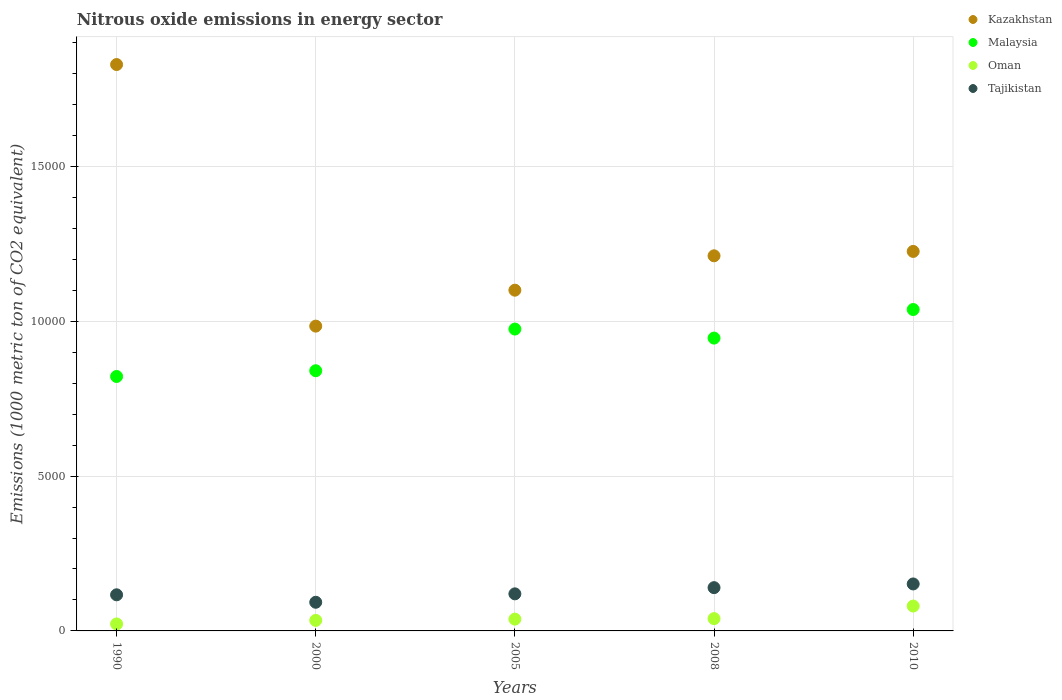How many different coloured dotlines are there?
Make the answer very short. 4. Is the number of dotlines equal to the number of legend labels?
Your answer should be very brief. Yes. What is the amount of nitrous oxide emitted in Malaysia in 1990?
Make the answer very short. 8218. Across all years, what is the maximum amount of nitrous oxide emitted in Tajikistan?
Provide a succinct answer. 1517. Across all years, what is the minimum amount of nitrous oxide emitted in Oman?
Provide a succinct answer. 225. In which year was the amount of nitrous oxide emitted in Oman minimum?
Ensure brevity in your answer.  1990. What is the total amount of nitrous oxide emitted in Malaysia in the graph?
Offer a very short reply. 4.62e+04. What is the difference between the amount of nitrous oxide emitted in Oman in 1990 and that in 2000?
Give a very brief answer. -115.4. What is the difference between the amount of nitrous oxide emitted in Malaysia in 2010 and the amount of nitrous oxide emitted in Oman in 2008?
Give a very brief answer. 9982.8. What is the average amount of nitrous oxide emitted in Tajikistan per year?
Keep it short and to the point. 1240.78. In the year 2008, what is the difference between the amount of nitrous oxide emitted in Kazakhstan and amount of nitrous oxide emitted in Tajikistan?
Make the answer very short. 1.07e+04. In how many years, is the amount of nitrous oxide emitted in Malaysia greater than 3000 1000 metric ton?
Keep it short and to the point. 5. What is the ratio of the amount of nitrous oxide emitted in Kazakhstan in 1990 to that in 2008?
Your answer should be very brief. 1.51. Is the difference between the amount of nitrous oxide emitted in Kazakhstan in 1990 and 2008 greater than the difference between the amount of nitrous oxide emitted in Tajikistan in 1990 and 2008?
Your response must be concise. Yes. What is the difference between the highest and the second highest amount of nitrous oxide emitted in Kazakhstan?
Make the answer very short. 6035.5. What is the difference between the highest and the lowest amount of nitrous oxide emitted in Oman?
Give a very brief answer. 578. In how many years, is the amount of nitrous oxide emitted in Tajikistan greater than the average amount of nitrous oxide emitted in Tajikistan taken over all years?
Give a very brief answer. 2. Is it the case that in every year, the sum of the amount of nitrous oxide emitted in Oman and amount of nitrous oxide emitted in Kazakhstan  is greater than the sum of amount of nitrous oxide emitted in Malaysia and amount of nitrous oxide emitted in Tajikistan?
Keep it short and to the point. Yes. Is it the case that in every year, the sum of the amount of nitrous oxide emitted in Kazakhstan and amount of nitrous oxide emitted in Oman  is greater than the amount of nitrous oxide emitted in Malaysia?
Your answer should be very brief. Yes. Is the amount of nitrous oxide emitted in Malaysia strictly greater than the amount of nitrous oxide emitted in Tajikistan over the years?
Keep it short and to the point. Yes. How many years are there in the graph?
Ensure brevity in your answer.  5. What is the difference between two consecutive major ticks on the Y-axis?
Your answer should be compact. 5000. Are the values on the major ticks of Y-axis written in scientific E-notation?
Give a very brief answer. No. Does the graph contain any zero values?
Offer a terse response. No. Does the graph contain grids?
Provide a succinct answer. Yes. How are the legend labels stacked?
Your response must be concise. Vertical. What is the title of the graph?
Provide a succinct answer. Nitrous oxide emissions in energy sector. What is the label or title of the X-axis?
Give a very brief answer. Years. What is the label or title of the Y-axis?
Keep it short and to the point. Emissions (1000 metric ton of CO2 equivalent). What is the Emissions (1000 metric ton of CO2 equivalent) of Kazakhstan in 1990?
Make the answer very short. 1.83e+04. What is the Emissions (1000 metric ton of CO2 equivalent) of Malaysia in 1990?
Provide a short and direct response. 8218. What is the Emissions (1000 metric ton of CO2 equivalent) of Oman in 1990?
Your response must be concise. 225. What is the Emissions (1000 metric ton of CO2 equivalent) of Tajikistan in 1990?
Offer a very short reply. 1166.5. What is the Emissions (1000 metric ton of CO2 equivalent) of Kazakhstan in 2000?
Ensure brevity in your answer.  9844.3. What is the Emissions (1000 metric ton of CO2 equivalent) in Malaysia in 2000?
Offer a very short reply. 8403.2. What is the Emissions (1000 metric ton of CO2 equivalent) of Oman in 2000?
Ensure brevity in your answer.  340.4. What is the Emissions (1000 metric ton of CO2 equivalent) in Tajikistan in 2000?
Your answer should be compact. 925.5. What is the Emissions (1000 metric ton of CO2 equivalent) of Kazakhstan in 2005?
Ensure brevity in your answer.  1.10e+04. What is the Emissions (1000 metric ton of CO2 equivalent) of Malaysia in 2005?
Your response must be concise. 9749.3. What is the Emissions (1000 metric ton of CO2 equivalent) of Oman in 2005?
Provide a succinct answer. 381.4. What is the Emissions (1000 metric ton of CO2 equivalent) of Tajikistan in 2005?
Your answer should be compact. 1197.3. What is the Emissions (1000 metric ton of CO2 equivalent) in Kazakhstan in 2008?
Make the answer very short. 1.21e+04. What is the Emissions (1000 metric ton of CO2 equivalent) of Malaysia in 2008?
Provide a succinct answer. 9457.6. What is the Emissions (1000 metric ton of CO2 equivalent) in Oman in 2008?
Keep it short and to the point. 397.4. What is the Emissions (1000 metric ton of CO2 equivalent) in Tajikistan in 2008?
Offer a very short reply. 1397.6. What is the Emissions (1000 metric ton of CO2 equivalent) in Kazakhstan in 2010?
Make the answer very short. 1.23e+04. What is the Emissions (1000 metric ton of CO2 equivalent) in Malaysia in 2010?
Give a very brief answer. 1.04e+04. What is the Emissions (1000 metric ton of CO2 equivalent) of Oman in 2010?
Give a very brief answer. 803. What is the Emissions (1000 metric ton of CO2 equivalent) in Tajikistan in 2010?
Your answer should be compact. 1517. Across all years, what is the maximum Emissions (1000 metric ton of CO2 equivalent) of Kazakhstan?
Ensure brevity in your answer.  1.83e+04. Across all years, what is the maximum Emissions (1000 metric ton of CO2 equivalent) of Malaysia?
Your response must be concise. 1.04e+04. Across all years, what is the maximum Emissions (1000 metric ton of CO2 equivalent) in Oman?
Make the answer very short. 803. Across all years, what is the maximum Emissions (1000 metric ton of CO2 equivalent) of Tajikistan?
Keep it short and to the point. 1517. Across all years, what is the minimum Emissions (1000 metric ton of CO2 equivalent) in Kazakhstan?
Your answer should be compact. 9844.3. Across all years, what is the minimum Emissions (1000 metric ton of CO2 equivalent) in Malaysia?
Give a very brief answer. 8218. Across all years, what is the minimum Emissions (1000 metric ton of CO2 equivalent) in Oman?
Your answer should be compact. 225. Across all years, what is the minimum Emissions (1000 metric ton of CO2 equivalent) of Tajikistan?
Keep it short and to the point. 925.5. What is the total Emissions (1000 metric ton of CO2 equivalent) of Kazakhstan in the graph?
Your answer should be very brief. 6.35e+04. What is the total Emissions (1000 metric ton of CO2 equivalent) in Malaysia in the graph?
Offer a very short reply. 4.62e+04. What is the total Emissions (1000 metric ton of CO2 equivalent) of Oman in the graph?
Offer a very short reply. 2147.2. What is the total Emissions (1000 metric ton of CO2 equivalent) of Tajikistan in the graph?
Offer a very short reply. 6203.9. What is the difference between the Emissions (1000 metric ton of CO2 equivalent) of Kazakhstan in 1990 and that in 2000?
Your answer should be very brief. 8448.2. What is the difference between the Emissions (1000 metric ton of CO2 equivalent) in Malaysia in 1990 and that in 2000?
Offer a terse response. -185.2. What is the difference between the Emissions (1000 metric ton of CO2 equivalent) of Oman in 1990 and that in 2000?
Your answer should be compact. -115.4. What is the difference between the Emissions (1000 metric ton of CO2 equivalent) of Tajikistan in 1990 and that in 2000?
Provide a short and direct response. 241. What is the difference between the Emissions (1000 metric ton of CO2 equivalent) in Kazakhstan in 1990 and that in 2005?
Make the answer very short. 7287.5. What is the difference between the Emissions (1000 metric ton of CO2 equivalent) of Malaysia in 1990 and that in 2005?
Your response must be concise. -1531.3. What is the difference between the Emissions (1000 metric ton of CO2 equivalent) of Oman in 1990 and that in 2005?
Provide a succinct answer. -156.4. What is the difference between the Emissions (1000 metric ton of CO2 equivalent) of Tajikistan in 1990 and that in 2005?
Your answer should be very brief. -30.8. What is the difference between the Emissions (1000 metric ton of CO2 equivalent) in Kazakhstan in 1990 and that in 2008?
Ensure brevity in your answer.  6177.4. What is the difference between the Emissions (1000 metric ton of CO2 equivalent) of Malaysia in 1990 and that in 2008?
Give a very brief answer. -1239.6. What is the difference between the Emissions (1000 metric ton of CO2 equivalent) of Oman in 1990 and that in 2008?
Make the answer very short. -172.4. What is the difference between the Emissions (1000 metric ton of CO2 equivalent) in Tajikistan in 1990 and that in 2008?
Offer a very short reply. -231.1. What is the difference between the Emissions (1000 metric ton of CO2 equivalent) of Kazakhstan in 1990 and that in 2010?
Keep it short and to the point. 6035.5. What is the difference between the Emissions (1000 metric ton of CO2 equivalent) of Malaysia in 1990 and that in 2010?
Make the answer very short. -2162.2. What is the difference between the Emissions (1000 metric ton of CO2 equivalent) of Oman in 1990 and that in 2010?
Your answer should be compact. -578. What is the difference between the Emissions (1000 metric ton of CO2 equivalent) in Tajikistan in 1990 and that in 2010?
Your response must be concise. -350.5. What is the difference between the Emissions (1000 metric ton of CO2 equivalent) in Kazakhstan in 2000 and that in 2005?
Make the answer very short. -1160.7. What is the difference between the Emissions (1000 metric ton of CO2 equivalent) of Malaysia in 2000 and that in 2005?
Offer a terse response. -1346.1. What is the difference between the Emissions (1000 metric ton of CO2 equivalent) in Oman in 2000 and that in 2005?
Ensure brevity in your answer.  -41. What is the difference between the Emissions (1000 metric ton of CO2 equivalent) in Tajikistan in 2000 and that in 2005?
Keep it short and to the point. -271.8. What is the difference between the Emissions (1000 metric ton of CO2 equivalent) in Kazakhstan in 2000 and that in 2008?
Ensure brevity in your answer.  -2270.8. What is the difference between the Emissions (1000 metric ton of CO2 equivalent) of Malaysia in 2000 and that in 2008?
Your response must be concise. -1054.4. What is the difference between the Emissions (1000 metric ton of CO2 equivalent) in Oman in 2000 and that in 2008?
Provide a succinct answer. -57. What is the difference between the Emissions (1000 metric ton of CO2 equivalent) of Tajikistan in 2000 and that in 2008?
Provide a succinct answer. -472.1. What is the difference between the Emissions (1000 metric ton of CO2 equivalent) in Kazakhstan in 2000 and that in 2010?
Provide a short and direct response. -2412.7. What is the difference between the Emissions (1000 metric ton of CO2 equivalent) in Malaysia in 2000 and that in 2010?
Ensure brevity in your answer.  -1977. What is the difference between the Emissions (1000 metric ton of CO2 equivalent) of Oman in 2000 and that in 2010?
Your response must be concise. -462.6. What is the difference between the Emissions (1000 metric ton of CO2 equivalent) of Tajikistan in 2000 and that in 2010?
Ensure brevity in your answer.  -591.5. What is the difference between the Emissions (1000 metric ton of CO2 equivalent) in Kazakhstan in 2005 and that in 2008?
Provide a short and direct response. -1110.1. What is the difference between the Emissions (1000 metric ton of CO2 equivalent) in Malaysia in 2005 and that in 2008?
Make the answer very short. 291.7. What is the difference between the Emissions (1000 metric ton of CO2 equivalent) of Tajikistan in 2005 and that in 2008?
Keep it short and to the point. -200.3. What is the difference between the Emissions (1000 metric ton of CO2 equivalent) in Kazakhstan in 2005 and that in 2010?
Your answer should be very brief. -1252. What is the difference between the Emissions (1000 metric ton of CO2 equivalent) in Malaysia in 2005 and that in 2010?
Ensure brevity in your answer.  -630.9. What is the difference between the Emissions (1000 metric ton of CO2 equivalent) of Oman in 2005 and that in 2010?
Your answer should be very brief. -421.6. What is the difference between the Emissions (1000 metric ton of CO2 equivalent) in Tajikistan in 2005 and that in 2010?
Your answer should be compact. -319.7. What is the difference between the Emissions (1000 metric ton of CO2 equivalent) of Kazakhstan in 2008 and that in 2010?
Make the answer very short. -141.9. What is the difference between the Emissions (1000 metric ton of CO2 equivalent) of Malaysia in 2008 and that in 2010?
Your response must be concise. -922.6. What is the difference between the Emissions (1000 metric ton of CO2 equivalent) in Oman in 2008 and that in 2010?
Keep it short and to the point. -405.6. What is the difference between the Emissions (1000 metric ton of CO2 equivalent) in Tajikistan in 2008 and that in 2010?
Make the answer very short. -119.4. What is the difference between the Emissions (1000 metric ton of CO2 equivalent) of Kazakhstan in 1990 and the Emissions (1000 metric ton of CO2 equivalent) of Malaysia in 2000?
Offer a terse response. 9889.3. What is the difference between the Emissions (1000 metric ton of CO2 equivalent) in Kazakhstan in 1990 and the Emissions (1000 metric ton of CO2 equivalent) in Oman in 2000?
Make the answer very short. 1.80e+04. What is the difference between the Emissions (1000 metric ton of CO2 equivalent) in Kazakhstan in 1990 and the Emissions (1000 metric ton of CO2 equivalent) in Tajikistan in 2000?
Your answer should be very brief. 1.74e+04. What is the difference between the Emissions (1000 metric ton of CO2 equivalent) of Malaysia in 1990 and the Emissions (1000 metric ton of CO2 equivalent) of Oman in 2000?
Give a very brief answer. 7877.6. What is the difference between the Emissions (1000 metric ton of CO2 equivalent) of Malaysia in 1990 and the Emissions (1000 metric ton of CO2 equivalent) of Tajikistan in 2000?
Your response must be concise. 7292.5. What is the difference between the Emissions (1000 metric ton of CO2 equivalent) in Oman in 1990 and the Emissions (1000 metric ton of CO2 equivalent) in Tajikistan in 2000?
Keep it short and to the point. -700.5. What is the difference between the Emissions (1000 metric ton of CO2 equivalent) of Kazakhstan in 1990 and the Emissions (1000 metric ton of CO2 equivalent) of Malaysia in 2005?
Offer a very short reply. 8543.2. What is the difference between the Emissions (1000 metric ton of CO2 equivalent) of Kazakhstan in 1990 and the Emissions (1000 metric ton of CO2 equivalent) of Oman in 2005?
Ensure brevity in your answer.  1.79e+04. What is the difference between the Emissions (1000 metric ton of CO2 equivalent) of Kazakhstan in 1990 and the Emissions (1000 metric ton of CO2 equivalent) of Tajikistan in 2005?
Provide a succinct answer. 1.71e+04. What is the difference between the Emissions (1000 metric ton of CO2 equivalent) of Malaysia in 1990 and the Emissions (1000 metric ton of CO2 equivalent) of Oman in 2005?
Give a very brief answer. 7836.6. What is the difference between the Emissions (1000 metric ton of CO2 equivalent) in Malaysia in 1990 and the Emissions (1000 metric ton of CO2 equivalent) in Tajikistan in 2005?
Your answer should be compact. 7020.7. What is the difference between the Emissions (1000 metric ton of CO2 equivalent) of Oman in 1990 and the Emissions (1000 metric ton of CO2 equivalent) of Tajikistan in 2005?
Keep it short and to the point. -972.3. What is the difference between the Emissions (1000 metric ton of CO2 equivalent) of Kazakhstan in 1990 and the Emissions (1000 metric ton of CO2 equivalent) of Malaysia in 2008?
Provide a succinct answer. 8834.9. What is the difference between the Emissions (1000 metric ton of CO2 equivalent) of Kazakhstan in 1990 and the Emissions (1000 metric ton of CO2 equivalent) of Oman in 2008?
Make the answer very short. 1.79e+04. What is the difference between the Emissions (1000 metric ton of CO2 equivalent) in Kazakhstan in 1990 and the Emissions (1000 metric ton of CO2 equivalent) in Tajikistan in 2008?
Provide a short and direct response. 1.69e+04. What is the difference between the Emissions (1000 metric ton of CO2 equivalent) of Malaysia in 1990 and the Emissions (1000 metric ton of CO2 equivalent) of Oman in 2008?
Ensure brevity in your answer.  7820.6. What is the difference between the Emissions (1000 metric ton of CO2 equivalent) of Malaysia in 1990 and the Emissions (1000 metric ton of CO2 equivalent) of Tajikistan in 2008?
Offer a very short reply. 6820.4. What is the difference between the Emissions (1000 metric ton of CO2 equivalent) of Oman in 1990 and the Emissions (1000 metric ton of CO2 equivalent) of Tajikistan in 2008?
Provide a short and direct response. -1172.6. What is the difference between the Emissions (1000 metric ton of CO2 equivalent) of Kazakhstan in 1990 and the Emissions (1000 metric ton of CO2 equivalent) of Malaysia in 2010?
Offer a very short reply. 7912.3. What is the difference between the Emissions (1000 metric ton of CO2 equivalent) of Kazakhstan in 1990 and the Emissions (1000 metric ton of CO2 equivalent) of Oman in 2010?
Offer a very short reply. 1.75e+04. What is the difference between the Emissions (1000 metric ton of CO2 equivalent) of Kazakhstan in 1990 and the Emissions (1000 metric ton of CO2 equivalent) of Tajikistan in 2010?
Offer a terse response. 1.68e+04. What is the difference between the Emissions (1000 metric ton of CO2 equivalent) in Malaysia in 1990 and the Emissions (1000 metric ton of CO2 equivalent) in Oman in 2010?
Your answer should be very brief. 7415. What is the difference between the Emissions (1000 metric ton of CO2 equivalent) in Malaysia in 1990 and the Emissions (1000 metric ton of CO2 equivalent) in Tajikistan in 2010?
Provide a succinct answer. 6701. What is the difference between the Emissions (1000 metric ton of CO2 equivalent) of Oman in 1990 and the Emissions (1000 metric ton of CO2 equivalent) of Tajikistan in 2010?
Ensure brevity in your answer.  -1292. What is the difference between the Emissions (1000 metric ton of CO2 equivalent) of Kazakhstan in 2000 and the Emissions (1000 metric ton of CO2 equivalent) of Malaysia in 2005?
Offer a terse response. 95. What is the difference between the Emissions (1000 metric ton of CO2 equivalent) in Kazakhstan in 2000 and the Emissions (1000 metric ton of CO2 equivalent) in Oman in 2005?
Your response must be concise. 9462.9. What is the difference between the Emissions (1000 metric ton of CO2 equivalent) in Kazakhstan in 2000 and the Emissions (1000 metric ton of CO2 equivalent) in Tajikistan in 2005?
Give a very brief answer. 8647. What is the difference between the Emissions (1000 metric ton of CO2 equivalent) in Malaysia in 2000 and the Emissions (1000 metric ton of CO2 equivalent) in Oman in 2005?
Provide a succinct answer. 8021.8. What is the difference between the Emissions (1000 metric ton of CO2 equivalent) of Malaysia in 2000 and the Emissions (1000 metric ton of CO2 equivalent) of Tajikistan in 2005?
Your answer should be very brief. 7205.9. What is the difference between the Emissions (1000 metric ton of CO2 equivalent) of Oman in 2000 and the Emissions (1000 metric ton of CO2 equivalent) of Tajikistan in 2005?
Your answer should be very brief. -856.9. What is the difference between the Emissions (1000 metric ton of CO2 equivalent) in Kazakhstan in 2000 and the Emissions (1000 metric ton of CO2 equivalent) in Malaysia in 2008?
Provide a short and direct response. 386.7. What is the difference between the Emissions (1000 metric ton of CO2 equivalent) of Kazakhstan in 2000 and the Emissions (1000 metric ton of CO2 equivalent) of Oman in 2008?
Ensure brevity in your answer.  9446.9. What is the difference between the Emissions (1000 metric ton of CO2 equivalent) in Kazakhstan in 2000 and the Emissions (1000 metric ton of CO2 equivalent) in Tajikistan in 2008?
Give a very brief answer. 8446.7. What is the difference between the Emissions (1000 metric ton of CO2 equivalent) of Malaysia in 2000 and the Emissions (1000 metric ton of CO2 equivalent) of Oman in 2008?
Ensure brevity in your answer.  8005.8. What is the difference between the Emissions (1000 metric ton of CO2 equivalent) of Malaysia in 2000 and the Emissions (1000 metric ton of CO2 equivalent) of Tajikistan in 2008?
Keep it short and to the point. 7005.6. What is the difference between the Emissions (1000 metric ton of CO2 equivalent) of Oman in 2000 and the Emissions (1000 metric ton of CO2 equivalent) of Tajikistan in 2008?
Keep it short and to the point. -1057.2. What is the difference between the Emissions (1000 metric ton of CO2 equivalent) in Kazakhstan in 2000 and the Emissions (1000 metric ton of CO2 equivalent) in Malaysia in 2010?
Your response must be concise. -535.9. What is the difference between the Emissions (1000 metric ton of CO2 equivalent) in Kazakhstan in 2000 and the Emissions (1000 metric ton of CO2 equivalent) in Oman in 2010?
Keep it short and to the point. 9041.3. What is the difference between the Emissions (1000 metric ton of CO2 equivalent) in Kazakhstan in 2000 and the Emissions (1000 metric ton of CO2 equivalent) in Tajikistan in 2010?
Keep it short and to the point. 8327.3. What is the difference between the Emissions (1000 metric ton of CO2 equivalent) of Malaysia in 2000 and the Emissions (1000 metric ton of CO2 equivalent) of Oman in 2010?
Provide a succinct answer. 7600.2. What is the difference between the Emissions (1000 metric ton of CO2 equivalent) of Malaysia in 2000 and the Emissions (1000 metric ton of CO2 equivalent) of Tajikistan in 2010?
Give a very brief answer. 6886.2. What is the difference between the Emissions (1000 metric ton of CO2 equivalent) of Oman in 2000 and the Emissions (1000 metric ton of CO2 equivalent) of Tajikistan in 2010?
Keep it short and to the point. -1176.6. What is the difference between the Emissions (1000 metric ton of CO2 equivalent) of Kazakhstan in 2005 and the Emissions (1000 metric ton of CO2 equivalent) of Malaysia in 2008?
Your response must be concise. 1547.4. What is the difference between the Emissions (1000 metric ton of CO2 equivalent) in Kazakhstan in 2005 and the Emissions (1000 metric ton of CO2 equivalent) in Oman in 2008?
Provide a succinct answer. 1.06e+04. What is the difference between the Emissions (1000 metric ton of CO2 equivalent) of Kazakhstan in 2005 and the Emissions (1000 metric ton of CO2 equivalent) of Tajikistan in 2008?
Provide a short and direct response. 9607.4. What is the difference between the Emissions (1000 metric ton of CO2 equivalent) in Malaysia in 2005 and the Emissions (1000 metric ton of CO2 equivalent) in Oman in 2008?
Keep it short and to the point. 9351.9. What is the difference between the Emissions (1000 metric ton of CO2 equivalent) in Malaysia in 2005 and the Emissions (1000 metric ton of CO2 equivalent) in Tajikistan in 2008?
Your answer should be very brief. 8351.7. What is the difference between the Emissions (1000 metric ton of CO2 equivalent) in Oman in 2005 and the Emissions (1000 metric ton of CO2 equivalent) in Tajikistan in 2008?
Offer a terse response. -1016.2. What is the difference between the Emissions (1000 metric ton of CO2 equivalent) in Kazakhstan in 2005 and the Emissions (1000 metric ton of CO2 equivalent) in Malaysia in 2010?
Provide a short and direct response. 624.8. What is the difference between the Emissions (1000 metric ton of CO2 equivalent) of Kazakhstan in 2005 and the Emissions (1000 metric ton of CO2 equivalent) of Oman in 2010?
Your answer should be very brief. 1.02e+04. What is the difference between the Emissions (1000 metric ton of CO2 equivalent) of Kazakhstan in 2005 and the Emissions (1000 metric ton of CO2 equivalent) of Tajikistan in 2010?
Offer a terse response. 9488. What is the difference between the Emissions (1000 metric ton of CO2 equivalent) of Malaysia in 2005 and the Emissions (1000 metric ton of CO2 equivalent) of Oman in 2010?
Your response must be concise. 8946.3. What is the difference between the Emissions (1000 metric ton of CO2 equivalent) of Malaysia in 2005 and the Emissions (1000 metric ton of CO2 equivalent) of Tajikistan in 2010?
Give a very brief answer. 8232.3. What is the difference between the Emissions (1000 metric ton of CO2 equivalent) of Oman in 2005 and the Emissions (1000 metric ton of CO2 equivalent) of Tajikistan in 2010?
Provide a succinct answer. -1135.6. What is the difference between the Emissions (1000 metric ton of CO2 equivalent) of Kazakhstan in 2008 and the Emissions (1000 metric ton of CO2 equivalent) of Malaysia in 2010?
Keep it short and to the point. 1734.9. What is the difference between the Emissions (1000 metric ton of CO2 equivalent) of Kazakhstan in 2008 and the Emissions (1000 metric ton of CO2 equivalent) of Oman in 2010?
Your response must be concise. 1.13e+04. What is the difference between the Emissions (1000 metric ton of CO2 equivalent) in Kazakhstan in 2008 and the Emissions (1000 metric ton of CO2 equivalent) in Tajikistan in 2010?
Offer a terse response. 1.06e+04. What is the difference between the Emissions (1000 metric ton of CO2 equivalent) of Malaysia in 2008 and the Emissions (1000 metric ton of CO2 equivalent) of Oman in 2010?
Offer a very short reply. 8654.6. What is the difference between the Emissions (1000 metric ton of CO2 equivalent) in Malaysia in 2008 and the Emissions (1000 metric ton of CO2 equivalent) in Tajikistan in 2010?
Provide a succinct answer. 7940.6. What is the difference between the Emissions (1000 metric ton of CO2 equivalent) in Oman in 2008 and the Emissions (1000 metric ton of CO2 equivalent) in Tajikistan in 2010?
Your response must be concise. -1119.6. What is the average Emissions (1000 metric ton of CO2 equivalent) in Kazakhstan per year?
Your answer should be very brief. 1.27e+04. What is the average Emissions (1000 metric ton of CO2 equivalent) of Malaysia per year?
Offer a very short reply. 9241.66. What is the average Emissions (1000 metric ton of CO2 equivalent) of Oman per year?
Your answer should be compact. 429.44. What is the average Emissions (1000 metric ton of CO2 equivalent) in Tajikistan per year?
Ensure brevity in your answer.  1240.78. In the year 1990, what is the difference between the Emissions (1000 metric ton of CO2 equivalent) of Kazakhstan and Emissions (1000 metric ton of CO2 equivalent) of Malaysia?
Your response must be concise. 1.01e+04. In the year 1990, what is the difference between the Emissions (1000 metric ton of CO2 equivalent) of Kazakhstan and Emissions (1000 metric ton of CO2 equivalent) of Oman?
Provide a short and direct response. 1.81e+04. In the year 1990, what is the difference between the Emissions (1000 metric ton of CO2 equivalent) in Kazakhstan and Emissions (1000 metric ton of CO2 equivalent) in Tajikistan?
Provide a short and direct response. 1.71e+04. In the year 1990, what is the difference between the Emissions (1000 metric ton of CO2 equivalent) in Malaysia and Emissions (1000 metric ton of CO2 equivalent) in Oman?
Make the answer very short. 7993. In the year 1990, what is the difference between the Emissions (1000 metric ton of CO2 equivalent) in Malaysia and Emissions (1000 metric ton of CO2 equivalent) in Tajikistan?
Ensure brevity in your answer.  7051.5. In the year 1990, what is the difference between the Emissions (1000 metric ton of CO2 equivalent) in Oman and Emissions (1000 metric ton of CO2 equivalent) in Tajikistan?
Give a very brief answer. -941.5. In the year 2000, what is the difference between the Emissions (1000 metric ton of CO2 equivalent) of Kazakhstan and Emissions (1000 metric ton of CO2 equivalent) of Malaysia?
Your answer should be very brief. 1441.1. In the year 2000, what is the difference between the Emissions (1000 metric ton of CO2 equivalent) in Kazakhstan and Emissions (1000 metric ton of CO2 equivalent) in Oman?
Provide a succinct answer. 9503.9. In the year 2000, what is the difference between the Emissions (1000 metric ton of CO2 equivalent) in Kazakhstan and Emissions (1000 metric ton of CO2 equivalent) in Tajikistan?
Your answer should be compact. 8918.8. In the year 2000, what is the difference between the Emissions (1000 metric ton of CO2 equivalent) of Malaysia and Emissions (1000 metric ton of CO2 equivalent) of Oman?
Keep it short and to the point. 8062.8. In the year 2000, what is the difference between the Emissions (1000 metric ton of CO2 equivalent) of Malaysia and Emissions (1000 metric ton of CO2 equivalent) of Tajikistan?
Your answer should be very brief. 7477.7. In the year 2000, what is the difference between the Emissions (1000 metric ton of CO2 equivalent) in Oman and Emissions (1000 metric ton of CO2 equivalent) in Tajikistan?
Provide a succinct answer. -585.1. In the year 2005, what is the difference between the Emissions (1000 metric ton of CO2 equivalent) of Kazakhstan and Emissions (1000 metric ton of CO2 equivalent) of Malaysia?
Your response must be concise. 1255.7. In the year 2005, what is the difference between the Emissions (1000 metric ton of CO2 equivalent) in Kazakhstan and Emissions (1000 metric ton of CO2 equivalent) in Oman?
Provide a short and direct response. 1.06e+04. In the year 2005, what is the difference between the Emissions (1000 metric ton of CO2 equivalent) of Kazakhstan and Emissions (1000 metric ton of CO2 equivalent) of Tajikistan?
Your answer should be very brief. 9807.7. In the year 2005, what is the difference between the Emissions (1000 metric ton of CO2 equivalent) of Malaysia and Emissions (1000 metric ton of CO2 equivalent) of Oman?
Your answer should be very brief. 9367.9. In the year 2005, what is the difference between the Emissions (1000 metric ton of CO2 equivalent) of Malaysia and Emissions (1000 metric ton of CO2 equivalent) of Tajikistan?
Provide a short and direct response. 8552. In the year 2005, what is the difference between the Emissions (1000 metric ton of CO2 equivalent) of Oman and Emissions (1000 metric ton of CO2 equivalent) of Tajikistan?
Your response must be concise. -815.9. In the year 2008, what is the difference between the Emissions (1000 metric ton of CO2 equivalent) of Kazakhstan and Emissions (1000 metric ton of CO2 equivalent) of Malaysia?
Offer a terse response. 2657.5. In the year 2008, what is the difference between the Emissions (1000 metric ton of CO2 equivalent) of Kazakhstan and Emissions (1000 metric ton of CO2 equivalent) of Oman?
Your answer should be very brief. 1.17e+04. In the year 2008, what is the difference between the Emissions (1000 metric ton of CO2 equivalent) of Kazakhstan and Emissions (1000 metric ton of CO2 equivalent) of Tajikistan?
Make the answer very short. 1.07e+04. In the year 2008, what is the difference between the Emissions (1000 metric ton of CO2 equivalent) in Malaysia and Emissions (1000 metric ton of CO2 equivalent) in Oman?
Offer a terse response. 9060.2. In the year 2008, what is the difference between the Emissions (1000 metric ton of CO2 equivalent) in Malaysia and Emissions (1000 metric ton of CO2 equivalent) in Tajikistan?
Give a very brief answer. 8060. In the year 2008, what is the difference between the Emissions (1000 metric ton of CO2 equivalent) in Oman and Emissions (1000 metric ton of CO2 equivalent) in Tajikistan?
Provide a succinct answer. -1000.2. In the year 2010, what is the difference between the Emissions (1000 metric ton of CO2 equivalent) in Kazakhstan and Emissions (1000 metric ton of CO2 equivalent) in Malaysia?
Provide a short and direct response. 1876.8. In the year 2010, what is the difference between the Emissions (1000 metric ton of CO2 equivalent) in Kazakhstan and Emissions (1000 metric ton of CO2 equivalent) in Oman?
Keep it short and to the point. 1.15e+04. In the year 2010, what is the difference between the Emissions (1000 metric ton of CO2 equivalent) in Kazakhstan and Emissions (1000 metric ton of CO2 equivalent) in Tajikistan?
Ensure brevity in your answer.  1.07e+04. In the year 2010, what is the difference between the Emissions (1000 metric ton of CO2 equivalent) of Malaysia and Emissions (1000 metric ton of CO2 equivalent) of Oman?
Keep it short and to the point. 9577.2. In the year 2010, what is the difference between the Emissions (1000 metric ton of CO2 equivalent) in Malaysia and Emissions (1000 metric ton of CO2 equivalent) in Tajikistan?
Provide a short and direct response. 8863.2. In the year 2010, what is the difference between the Emissions (1000 metric ton of CO2 equivalent) in Oman and Emissions (1000 metric ton of CO2 equivalent) in Tajikistan?
Your answer should be very brief. -714. What is the ratio of the Emissions (1000 metric ton of CO2 equivalent) in Kazakhstan in 1990 to that in 2000?
Ensure brevity in your answer.  1.86. What is the ratio of the Emissions (1000 metric ton of CO2 equivalent) in Malaysia in 1990 to that in 2000?
Your response must be concise. 0.98. What is the ratio of the Emissions (1000 metric ton of CO2 equivalent) in Oman in 1990 to that in 2000?
Provide a short and direct response. 0.66. What is the ratio of the Emissions (1000 metric ton of CO2 equivalent) in Tajikistan in 1990 to that in 2000?
Your answer should be very brief. 1.26. What is the ratio of the Emissions (1000 metric ton of CO2 equivalent) of Kazakhstan in 1990 to that in 2005?
Your answer should be very brief. 1.66. What is the ratio of the Emissions (1000 metric ton of CO2 equivalent) of Malaysia in 1990 to that in 2005?
Make the answer very short. 0.84. What is the ratio of the Emissions (1000 metric ton of CO2 equivalent) of Oman in 1990 to that in 2005?
Keep it short and to the point. 0.59. What is the ratio of the Emissions (1000 metric ton of CO2 equivalent) in Tajikistan in 1990 to that in 2005?
Offer a very short reply. 0.97. What is the ratio of the Emissions (1000 metric ton of CO2 equivalent) of Kazakhstan in 1990 to that in 2008?
Provide a succinct answer. 1.51. What is the ratio of the Emissions (1000 metric ton of CO2 equivalent) of Malaysia in 1990 to that in 2008?
Your answer should be compact. 0.87. What is the ratio of the Emissions (1000 metric ton of CO2 equivalent) in Oman in 1990 to that in 2008?
Ensure brevity in your answer.  0.57. What is the ratio of the Emissions (1000 metric ton of CO2 equivalent) in Tajikistan in 1990 to that in 2008?
Provide a succinct answer. 0.83. What is the ratio of the Emissions (1000 metric ton of CO2 equivalent) in Kazakhstan in 1990 to that in 2010?
Keep it short and to the point. 1.49. What is the ratio of the Emissions (1000 metric ton of CO2 equivalent) of Malaysia in 1990 to that in 2010?
Ensure brevity in your answer.  0.79. What is the ratio of the Emissions (1000 metric ton of CO2 equivalent) of Oman in 1990 to that in 2010?
Your answer should be compact. 0.28. What is the ratio of the Emissions (1000 metric ton of CO2 equivalent) in Tajikistan in 1990 to that in 2010?
Provide a short and direct response. 0.77. What is the ratio of the Emissions (1000 metric ton of CO2 equivalent) in Kazakhstan in 2000 to that in 2005?
Offer a terse response. 0.89. What is the ratio of the Emissions (1000 metric ton of CO2 equivalent) of Malaysia in 2000 to that in 2005?
Offer a terse response. 0.86. What is the ratio of the Emissions (1000 metric ton of CO2 equivalent) of Oman in 2000 to that in 2005?
Give a very brief answer. 0.89. What is the ratio of the Emissions (1000 metric ton of CO2 equivalent) in Tajikistan in 2000 to that in 2005?
Provide a succinct answer. 0.77. What is the ratio of the Emissions (1000 metric ton of CO2 equivalent) in Kazakhstan in 2000 to that in 2008?
Provide a short and direct response. 0.81. What is the ratio of the Emissions (1000 metric ton of CO2 equivalent) in Malaysia in 2000 to that in 2008?
Offer a terse response. 0.89. What is the ratio of the Emissions (1000 metric ton of CO2 equivalent) of Oman in 2000 to that in 2008?
Give a very brief answer. 0.86. What is the ratio of the Emissions (1000 metric ton of CO2 equivalent) of Tajikistan in 2000 to that in 2008?
Give a very brief answer. 0.66. What is the ratio of the Emissions (1000 metric ton of CO2 equivalent) in Kazakhstan in 2000 to that in 2010?
Provide a succinct answer. 0.8. What is the ratio of the Emissions (1000 metric ton of CO2 equivalent) in Malaysia in 2000 to that in 2010?
Ensure brevity in your answer.  0.81. What is the ratio of the Emissions (1000 metric ton of CO2 equivalent) in Oman in 2000 to that in 2010?
Provide a succinct answer. 0.42. What is the ratio of the Emissions (1000 metric ton of CO2 equivalent) of Tajikistan in 2000 to that in 2010?
Provide a short and direct response. 0.61. What is the ratio of the Emissions (1000 metric ton of CO2 equivalent) in Kazakhstan in 2005 to that in 2008?
Provide a short and direct response. 0.91. What is the ratio of the Emissions (1000 metric ton of CO2 equivalent) of Malaysia in 2005 to that in 2008?
Keep it short and to the point. 1.03. What is the ratio of the Emissions (1000 metric ton of CO2 equivalent) in Oman in 2005 to that in 2008?
Keep it short and to the point. 0.96. What is the ratio of the Emissions (1000 metric ton of CO2 equivalent) of Tajikistan in 2005 to that in 2008?
Provide a succinct answer. 0.86. What is the ratio of the Emissions (1000 metric ton of CO2 equivalent) in Kazakhstan in 2005 to that in 2010?
Your answer should be very brief. 0.9. What is the ratio of the Emissions (1000 metric ton of CO2 equivalent) in Malaysia in 2005 to that in 2010?
Ensure brevity in your answer.  0.94. What is the ratio of the Emissions (1000 metric ton of CO2 equivalent) in Oman in 2005 to that in 2010?
Offer a terse response. 0.47. What is the ratio of the Emissions (1000 metric ton of CO2 equivalent) in Tajikistan in 2005 to that in 2010?
Keep it short and to the point. 0.79. What is the ratio of the Emissions (1000 metric ton of CO2 equivalent) of Kazakhstan in 2008 to that in 2010?
Make the answer very short. 0.99. What is the ratio of the Emissions (1000 metric ton of CO2 equivalent) in Malaysia in 2008 to that in 2010?
Keep it short and to the point. 0.91. What is the ratio of the Emissions (1000 metric ton of CO2 equivalent) of Oman in 2008 to that in 2010?
Keep it short and to the point. 0.49. What is the ratio of the Emissions (1000 metric ton of CO2 equivalent) of Tajikistan in 2008 to that in 2010?
Provide a succinct answer. 0.92. What is the difference between the highest and the second highest Emissions (1000 metric ton of CO2 equivalent) in Kazakhstan?
Keep it short and to the point. 6035.5. What is the difference between the highest and the second highest Emissions (1000 metric ton of CO2 equivalent) in Malaysia?
Give a very brief answer. 630.9. What is the difference between the highest and the second highest Emissions (1000 metric ton of CO2 equivalent) of Oman?
Provide a short and direct response. 405.6. What is the difference between the highest and the second highest Emissions (1000 metric ton of CO2 equivalent) of Tajikistan?
Your answer should be compact. 119.4. What is the difference between the highest and the lowest Emissions (1000 metric ton of CO2 equivalent) in Kazakhstan?
Make the answer very short. 8448.2. What is the difference between the highest and the lowest Emissions (1000 metric ton of CO2 equivalent) in Malaysia?
Make the answer very short. 2162.2. What is the difference between the highest and the lowest Emissions (1000 metric ton of CO2 equivalent) in Oman?
Provide a succinct answer. 578. What is the difference between the highest and the lowest Emissions (1000 metric ton of CO2 equivalent) in Tajikistan?
Give a very brief answer. 591.5. 